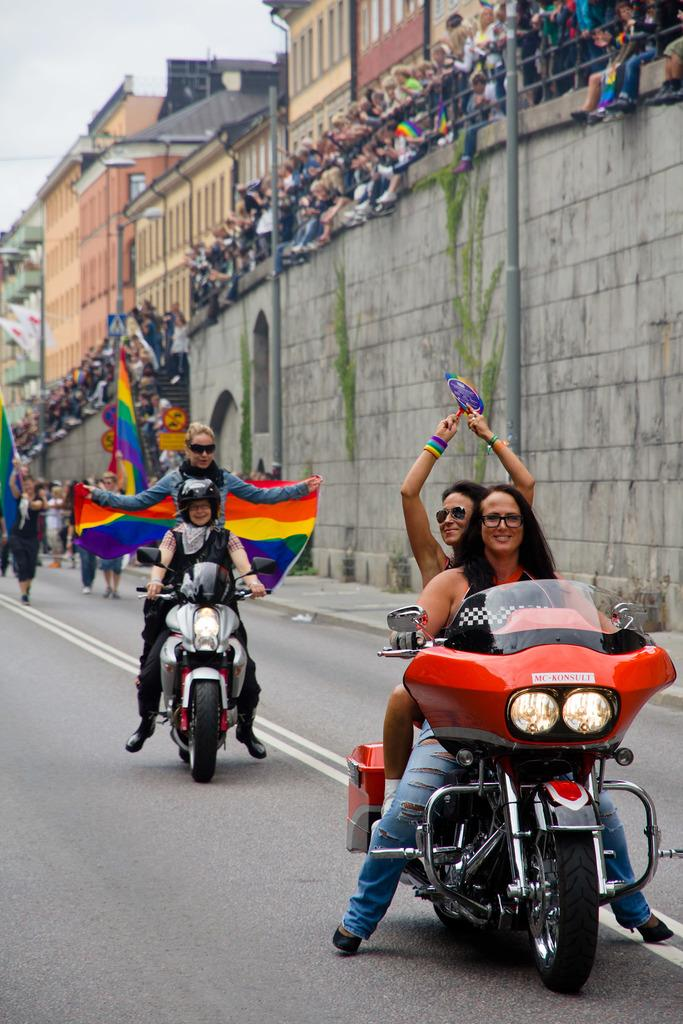What are the persons in the image doing? The persons in the image are riding bikes on the road. Are there any other people present in the image? Yes, there are other persons standing nearby. What type of structure can be seen in the image? There is a building in the image. What is visible at the top of the image? The sky is visible at the top of the image. What type of guide is present in the image to help the persons riding bikes? There is no guide present in the image; the persons riding bikes appear to be on their own. What story is being told by the persons standing nearby in the image? There is no story being told in the image; the persons standing nearby are not engaged in any apparent conversation or activity. 